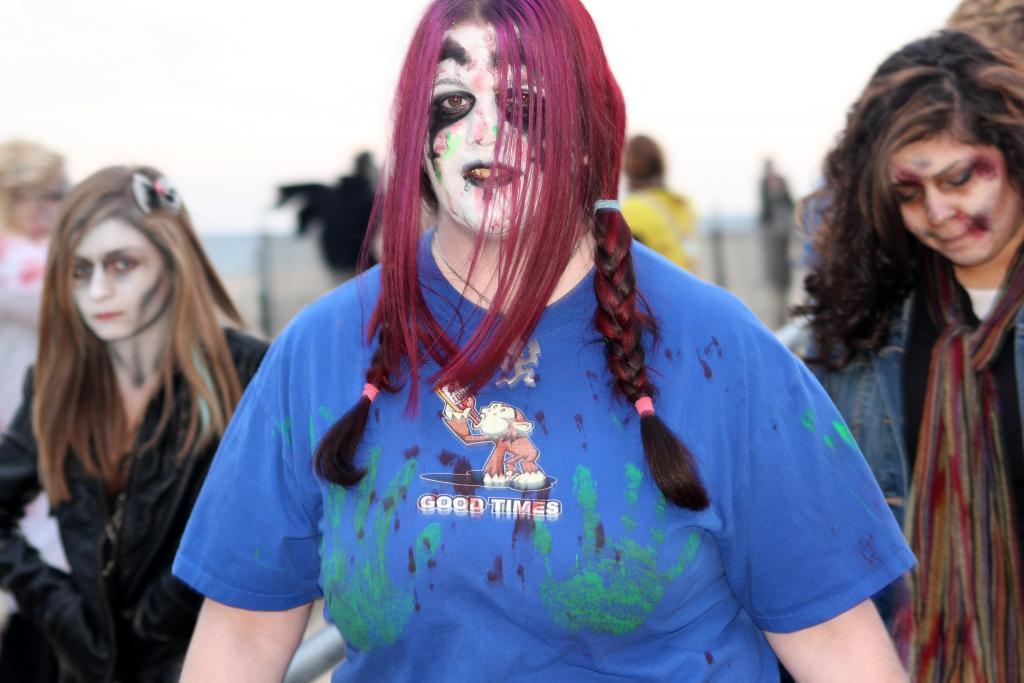Can you describe this image briefly? In this picture there are three women who are standing on the road. In the back I can see the blur image. At the top there is a sky. 